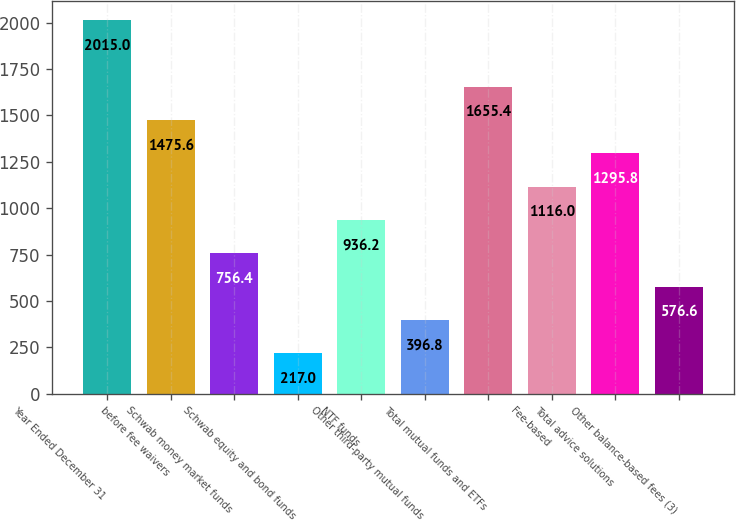Convert chart to OTSL. <chart><loc_0><loc_0><loc_500><loc_500><bar_chart><fcel>Year Ended December 31<fcel>before fee waivers<fcel>Schwab money market funds<fcel>Schwab equity and bond funds<fcel>NTF funds<fcel>Other third-party mutual funds<fcel>Total mutual funds and ETFs<fcel>Fee-based<fcel>Total advice solutions<fcel>Other balance-based fees (3)<nl><fcel>2015<fcel>1475.6<fcel>756.4<fcel>217<fcel>936.2<fcel>396.8<fcel>1655.4<fcel>1116<fcel>1295.8<fcel>576.6<nl></chart> 